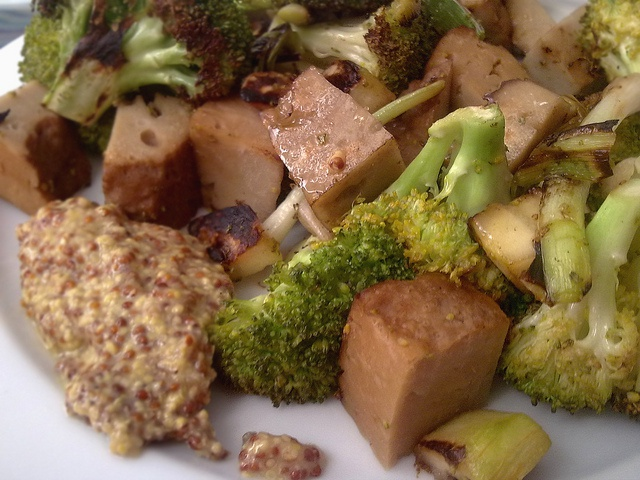Describe the objects in this image and their specific colors. I can see broccoli in white, black, olive, and maroon tones, broccoli in white, olive, and black tones, broccoli in white, olive, and black tones, broccoli in white and olive tones, and broccoli in white, black, maroon, olive, and tan tones in this image. 